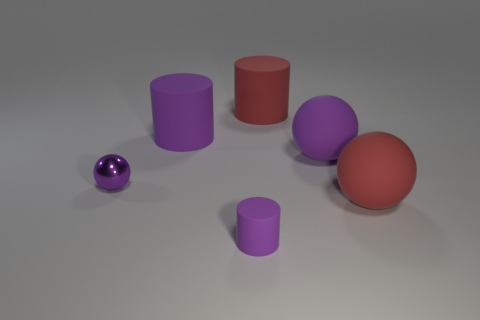Add 2 tiny red things. How many objects exist? 8 Add 2 big matte balls. How many big matte balls are left? 4 Add 6 large red rubber objects. How many large red rubber objects exist? 8 Subtract 0 gray spheres. How many objects are left? 6 Subtract all purple rubber cylinders. Subtract all big brown cylinders. How many objects are left? 4 